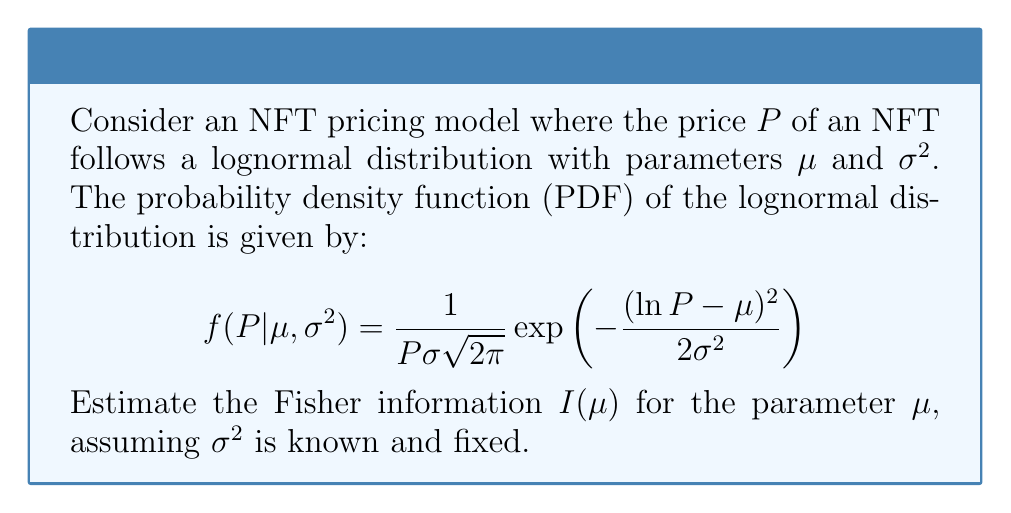What is the answer to this math problem? To estimate the Fisher information for $\mu$, we follow these steps:

1) The Fisher information is defined as:
   $$I(\mu) = -E\left[\frac{\partial^2}{\partial\mu^2} \ln f(P|\mu,\sigma^2)\right]$$

2) First, we calculate $\ln f(P|\mu,\sigma^2)$:
   $$\ln f(P|\mu,\sigma^2) = -\ln P - \ln(\sigma\sqrt{2\pi}) - \frac{(\ln P - \mu)^2}{2\sigma^2}$$

3) Next, we take the first derivative with respect to $\mu$:
   $$\frac{\partial}{\partial\mu} \ln f(P|\mu,\sigma^2) = \frac{\ln P - \mu}{\sigma^2}$$

4) Then, we take the second derivative:
   $$\frac{\partial^2}{\partial\mu^2} \ln f(P|\mu,\sigma^2) = -\frac{1}{\sigma^2}$$

5) The Fisher information is the negative expectation of this second derivative:
   $$I(\mu) = -E\left[-\frac{1}{\sigma^2}\right] = \frac{1}{\sigma^2}$$

6) Note that this result is constant and doesn't depend on $P$ or $\mu$, only on $\sigma^2$.

Therefore, the Fisher information for $\mu$ in this NFT pricing model is $\frac{1}{\sigma^2}$.
Answer: $I(\mu) = \frac{1}{\sigma^2}$ 